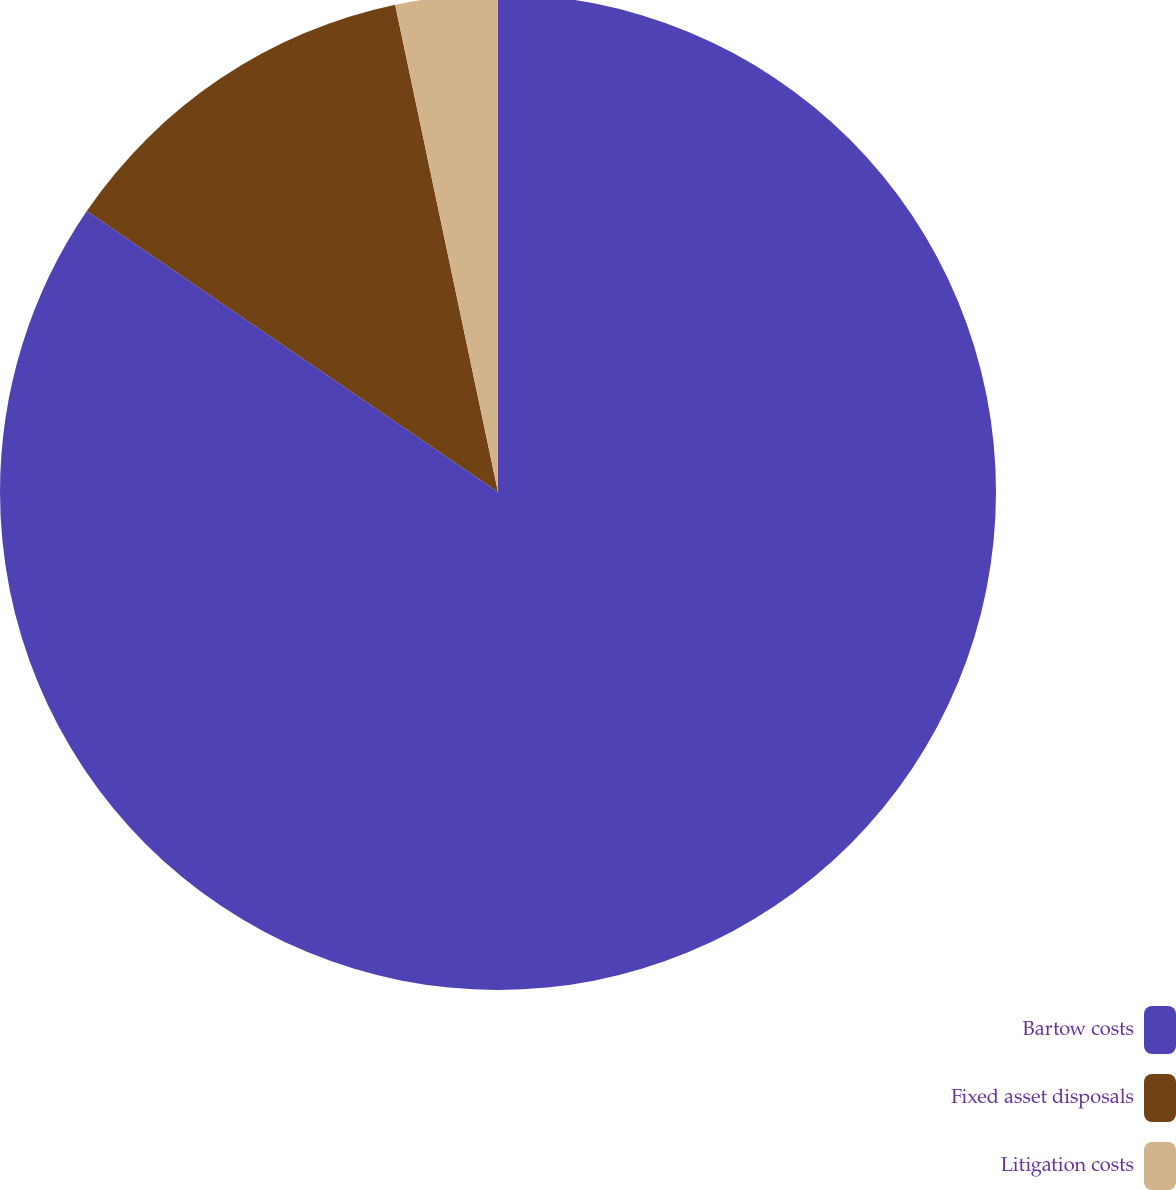Convert chart to OTSL. <chart><loc_0><loc_0><loc_500><loc_500><pie_chart><fcel>Bartow costs<fcel>Fixed asset disposals<fcel>Litigation costs<nl><fcel>84.53%<fcel>12.15%<fcel>3.31%<nl></chart> 